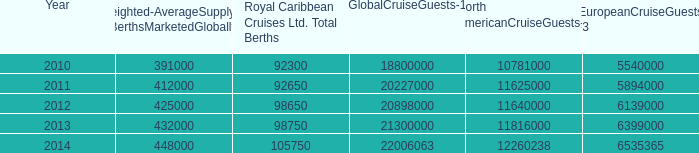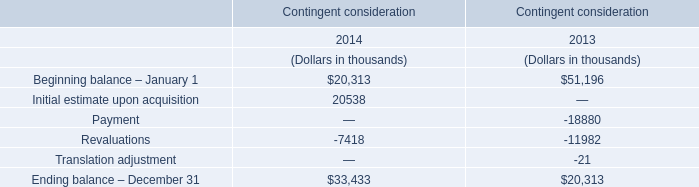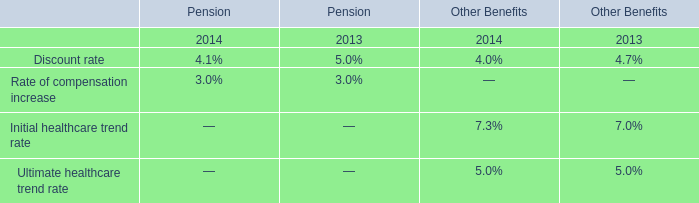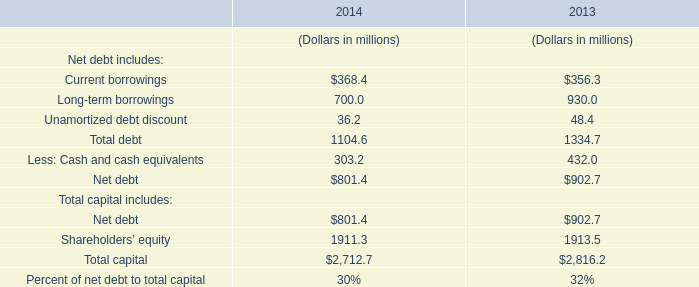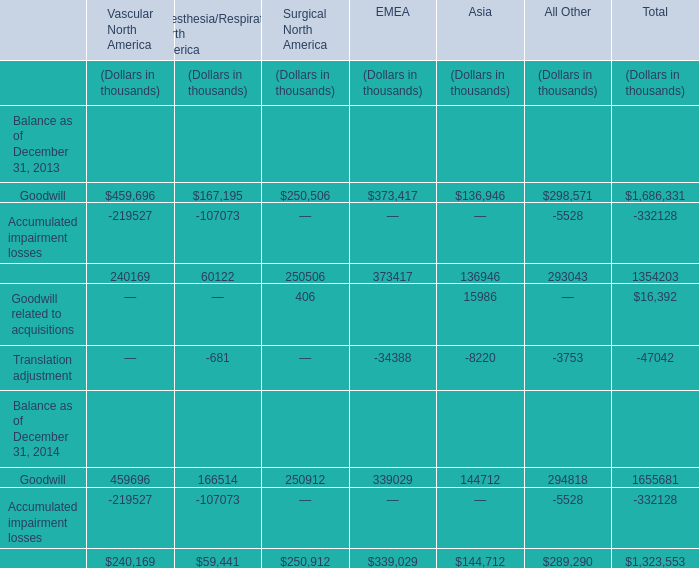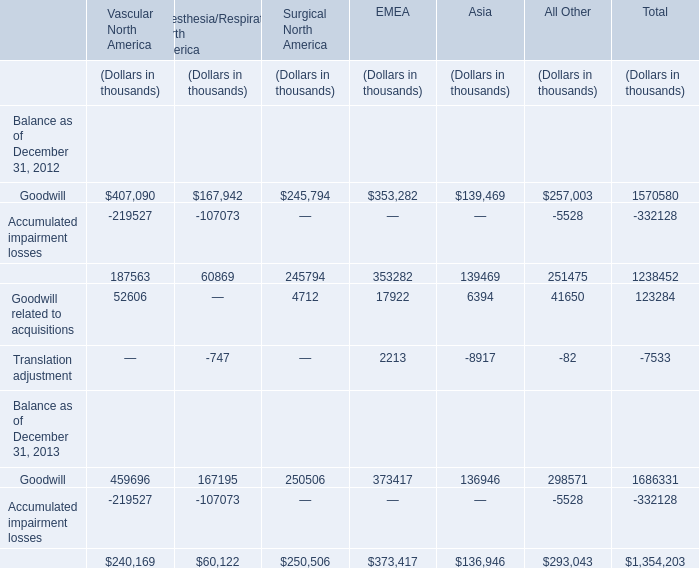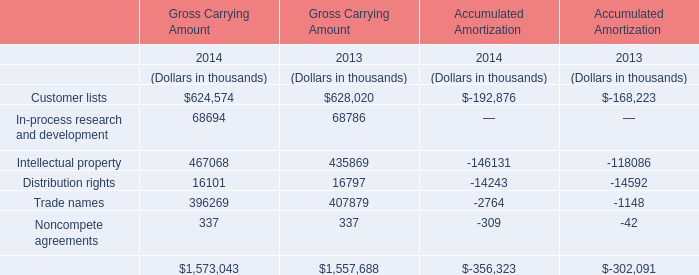Which Goodwill related to acquisitions exceeds 30% of total in 2012? 
Computations: (123284 * 0.3)
Answer: 36985.2. 